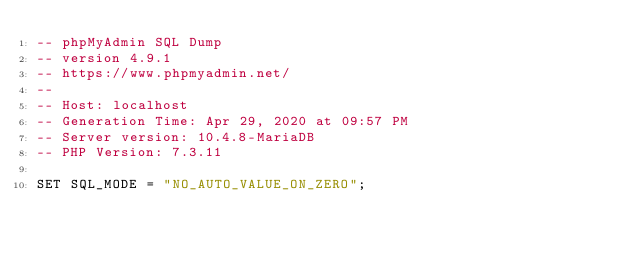<code> <loc_0><loc_0><loc_500><loc_500><_SQL_>-- phpMyAdmin SQL Dump
-- version 4.9.1
-- https://www.phpmyadmin.net/
--
-- Host: localhost
-- Generation Time: Apr 29, 2020 at 09:57 PM
-- Server version: 10.4.8-MariaDB
-- PHP Version: 7.3.11

SET SQL_MODE = "NO_AUTO_VALUE_ON_ZERO";</code> 